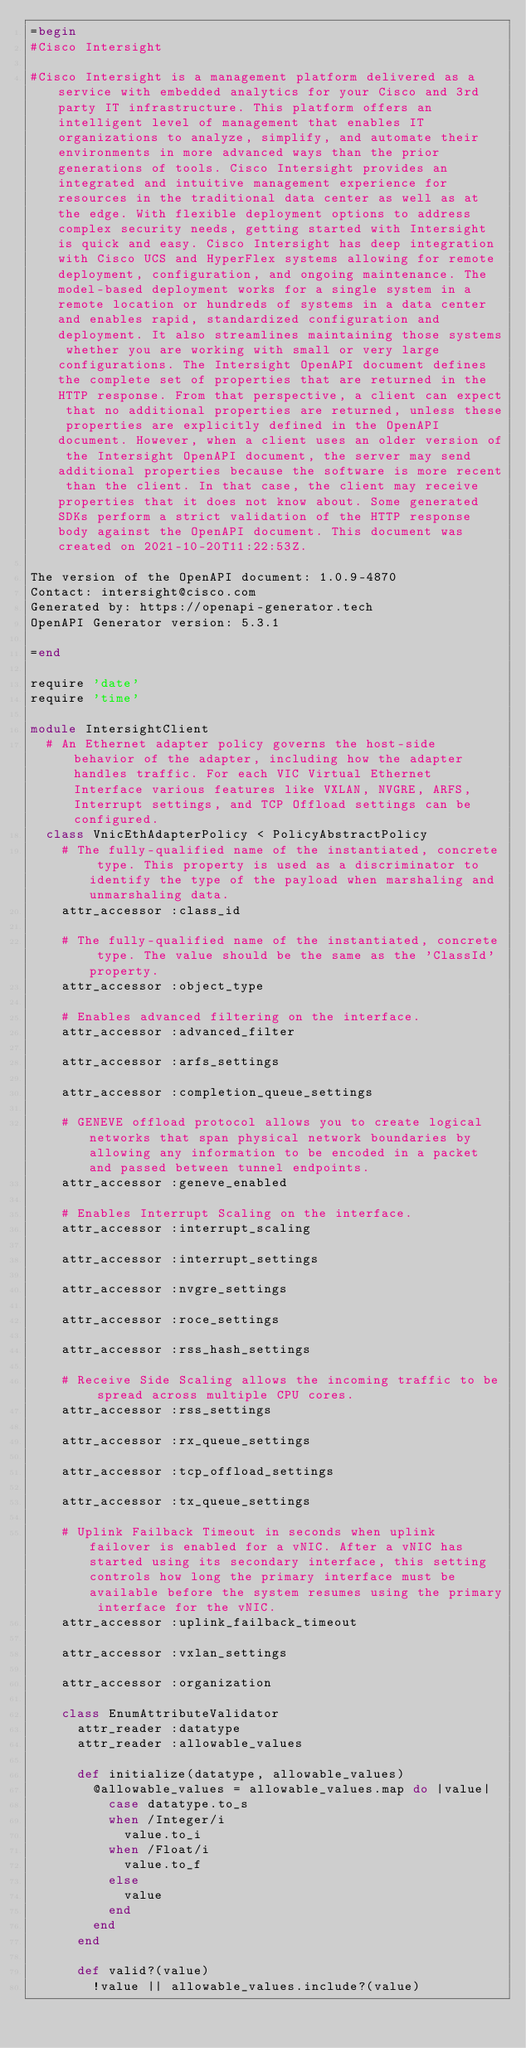<code> <loc_0><loc_0><loc_500><loc_500><_Ruby_>=begin
#Cisco Intersight

#Cisco Intersight is a management platform delivered as a service with embedded analytics for your Cisco and 3rd party IT infrastructure. This platform offers an intelligent level of management that enables IT organizations to analyze, simplify, and automate their environments in more advanced ways than the prior generations of tools. Cisco Intersight provides an integrated and intuitive management experience for resources in the traditional data center as well as at the edge. With flexible deployment options to address complex security needs, getting started with Intersight is quick and easy. Cisco Intersight has deep integration with Cisco UCS and HyperFlex systems allowing for remote deployment, configuration, and ongoing maintenance. The model-based deployment works for a single system in a remote location or hundreds of systems in a data center and enables rapid, standardized configuration and deployment. It also streamlines maintaining those systems whether you are working with small or very large configurations. The Intersight OpenAPI document defines the complete set of properties that are returned in the HTTP response. From that perspective, a client can expect that no additional properties are returned, unless these properties are explicitly defined in the OpenAPI document. However, when a client uses an older version of the Intersight OpenAPI document, the server may send additional properties because the software is more recent than the client. In that case, the client may receive properties that it does not know about. Some generated SDKs perform a strict validation of the HTTP response body against the OpenAPI document. This document was created on 2021-10-20T11:22:53Z.

The version of the OpenAPI document: 1.0.9-4870
Contact: intersight@cisco.com
Generated by: https://openapi-generator.tech
OpenAPI Generator version: 5.3.1

=end

require 'date'
require 'time'

module IntersightClient
  # An Ethernet adapter policy governs the host-side behavior of the adapter, including how the adapter handles traffic. For each VIC Virtual Ethernet Interface various features like VXLAN, NVGRE, ARFS, Interrupt settings, and TCP Offload settings can be configured.
  class VnicEthAdapterPolicy < PolicyAbstractPolicy
    # The fully-qualified name of the instantiated, concrete type. This property is used as a discriminator to identify the type of the payload when marshaling and unmarshaling data.
    attr_accessor :class_id

    # The fully-qualified name of the instantiated, concrete type. The value should be the same as the 'ClassId' property.
    attr_accessor :object_type

    # Enables advanced filtering on the interface.
    attr_accessor :advanced_filter

    attr_accessor :arfs_settings

    attr_accessor :completion_queue_settings

    # GENEVE offload protocol allows you to create logical networks that span physical network boundaries by allowing any information to be encoded in a packet and passed between tunnel endpoints.
    attr_accessor :geneve_enabled

    # Enables Interrupt Scaling on the interface.
    attr_accessor :interrupt_scaling

    attr_accessor :interrupt_settings

    attr_accessor :nvgre_settings

    attr_accessor :roce_settings

    attr_accessor :rss_hash_settings

    # Receive Side Scaling allows the incoming traffic to be spread across multiple CPU cores.
    attr_accessor :rss_settings

    attr_accessor :rx_queue_settings

    attr_accessor :tcp_offload_settings

    attr_accessor :tx_queue_settings

    # Uplink Failback Timeout in seconds when uplink failover is enabled for a vNIC. After a vNIC has started using its secondary interface, this setting controls how long the primary interface must be available before the system resumes using the primary interface for the vNIC.
    attr_accessor :uplink_failback_timeout

    attr_accessor :vxlan_settings

    attr_accessor :organization

    class EnumAttributeValidator
      attr_reader :datatype
      attr_reader :allowable_values

      def initialize(datatype, allowable_values)
        @allowable_values = allowable_values.map do |value|
          case datatype.to_s
          when /Integer/i
            value.to_i
          when /Float/i
            value.to_f
          else
            value
          end
        end
      end

      def valid?(value)
        !value || allowable_values.include?(value)</code> 